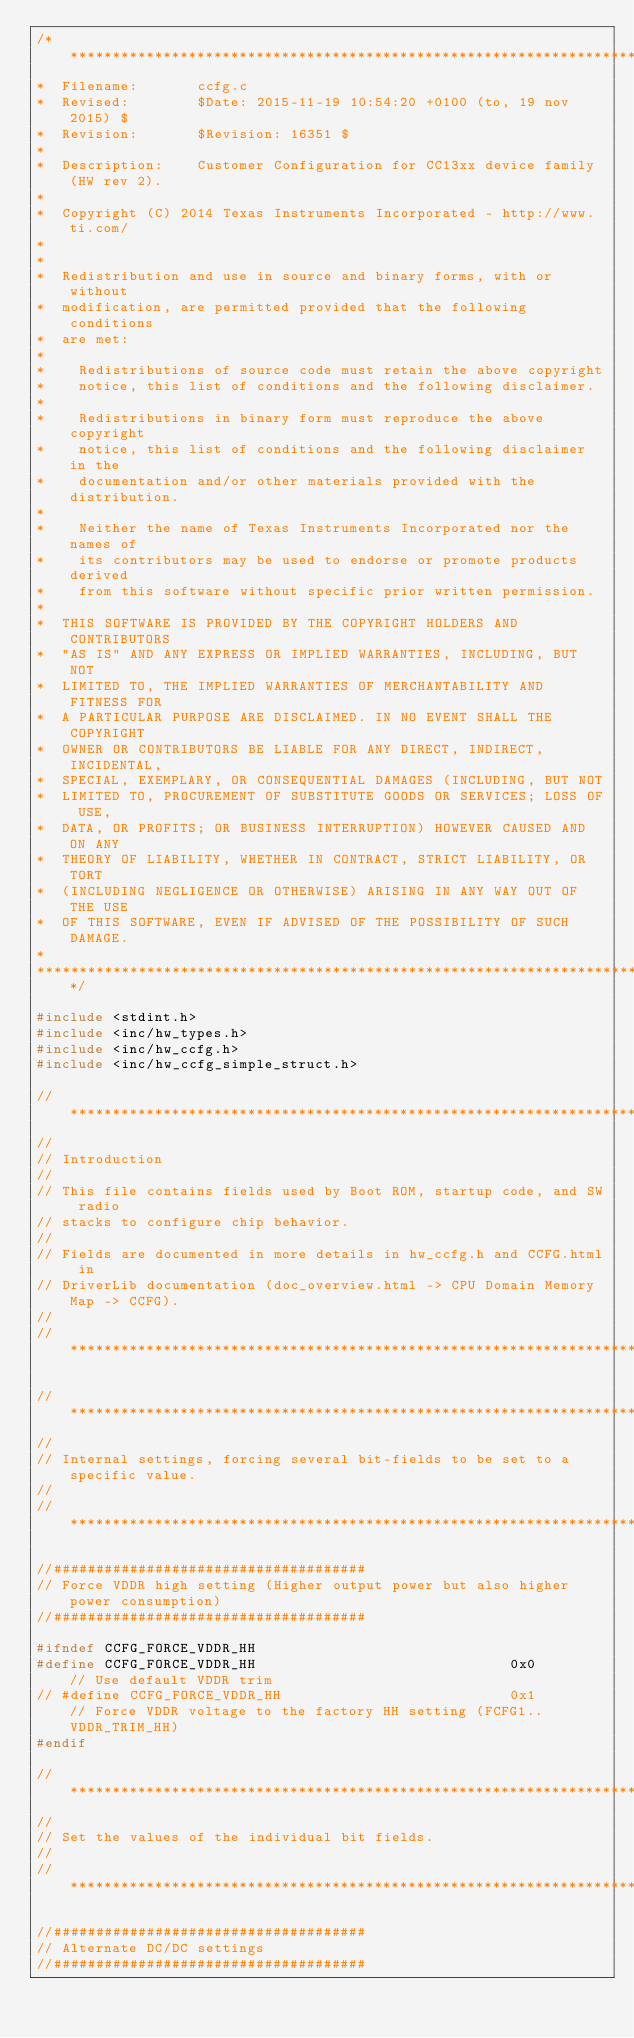<code> <loc_0><loc_0><loc_500><loc_500><_C_>/******************************************************************************
*  Filename:       ccfg.c
*  Revised:        $Date: 2015-11-19 10:54:20 +0100 (to, 19 nov 2015) $
*  Revision:       $Revision: 16351 $
*
*  Description:    Customer Configuration for CC13xx device family (HW rev 2).
*
*  Copyright (C) 2014 Texas Instruments Incorporated - http://www.ti.com/
*
*
*  Redistribution and use in source and binary forms, with or without
*  modification, are permitted provided that the following conditions
*  are met:
*
*    Redistributions of source code must retain the above copyright
*    notice, this list of conditions and the following disclaimer.
*
*    Redistributions in binary form must reproduce the above copyright
*    notice, this list of conditions and the following disclaimer in the
*    documentation and/or other materials provided with the distribution.
*
*    Neither the name of Texas Instruments Incorporated nor the names of
*    its contributors may be used to endorse or promote products derived
*    from this software without specific prior written permission.
*
*  THIS SOFTWARE IS PROVIDED BY THE COPYRIGHT HOLDERS AND CONTRIBUTORS
*  "AS IS" AND ANY EXPRESS OR IMPLIED WARRANTIES, INCLUDING, BUT NOT
*  LIMITED TO, THE IMPLIED WARRANTIES OF MERCHANTABILITY AND FITNESS FOR
*  A PARTICULAR PURPOSE ARE DISCLAIMED. IN NO EVENT SHALL THE COPYRIGHT
*  OWNER OR CONTRIBUTORS BE LIABLE FOR ANY DIRECT, INDIRECT, INCIDENTAL,
*  SPECIAL, EXEMPLARY, OR CONSEQUENTIAL DAMAGES (INCLUDING, BUT NOT
*  LIMITED TO, PROCUREMENT OF SUBSTITUTE GOODS OR SERVICES; LOSS OF USE,
*  DATA, OR PROFITS; OR BUSINESS INTERRUPTION) HOWEVER CAUSED AND ON ANY
*  THEORY OF LIABILITY, WHETHER IN CONTRACT, STRICT LIABILITY, OR TORT
*  (INCLUDING NEGLIGENCE OR OTHERWISE) ARISING IN ANY WAY OUT OF THE USE
*  OF THIS SOFTWARE, EVEN IF ADVISED OF THE POSSIBILITY OF SUCH DAMAGE.
*
******************************************************************************/

#include <stdint.h>
#include <inc/hw_types.h>
#include <inc/hw_ccfg.h>
#include <inc/hw_ccfg_simple_struct.h>

//*****************************************************************************
//
// Introduction
//
// This file contains fields used by Boot ROM, startup code, and SW radio 
// stacks to configure chip behavior.
//
// Fields are documented in more details in hw_ccfg.h and CCFG.html in 
// DriverLib documentation (doc_overview.html -> CPU Domain Memory Map -> CCFG).
//
//*****************************************************************************

//*****************************************************************************
//
// Internal settings, forcing several bit-fields to be set to a specific value.
//
//*****************************************************************************

//#####################################
// Force VDDR high setting (Higher output power but also higher power consumption)
//#####################################

#ifndef CCFG_FORCE_VDDR_HH
#define CCFG_FORCE_VDDR_HH                              0x0        // Use default VDDR trim
// #define CCFG_FORCE_VDDR_HH                           0x1        // Force VDDR voltage to the factory HH setting (FCFG1..VDDR_TRIM_HH)
#endif

//*****************************************************************************
//
// Set the values of the individual bit fields.
//
//*****************************************************************************

//#####################################
// Alternate DC/DC settings
//#####################################
</code> 